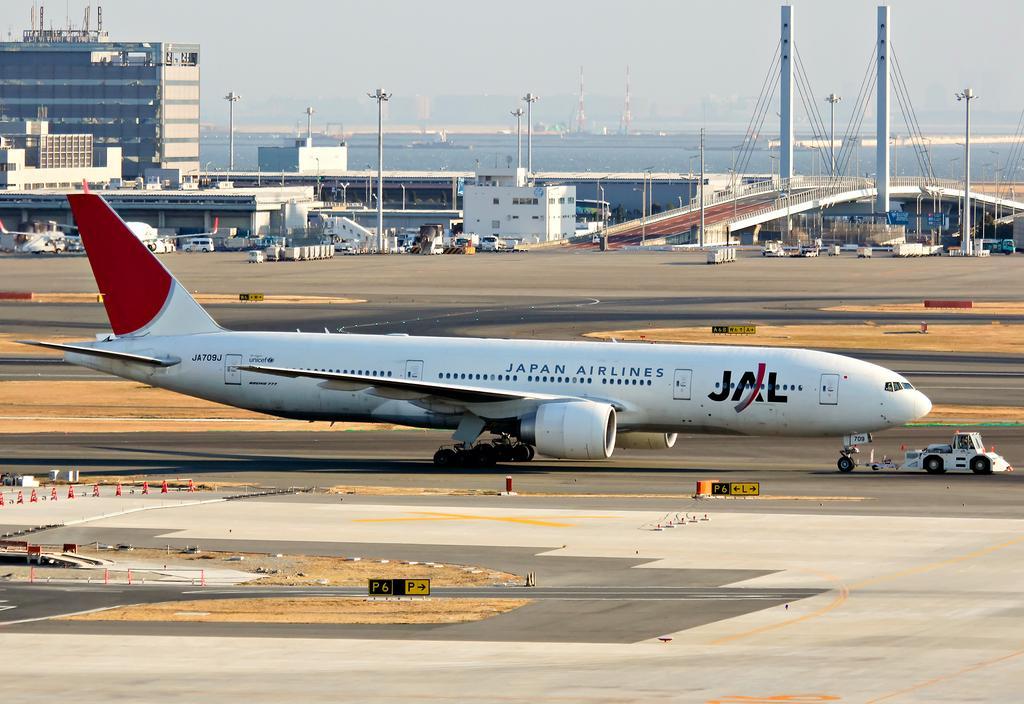In one or two sentences, can you explain what this image depicts? In this picture I can see airplanes on the runway, there are vehicles, cone barriers, poles, lights, buildings, there is a bridge, there is water, those are looking like towers, and in the background there is sky. 